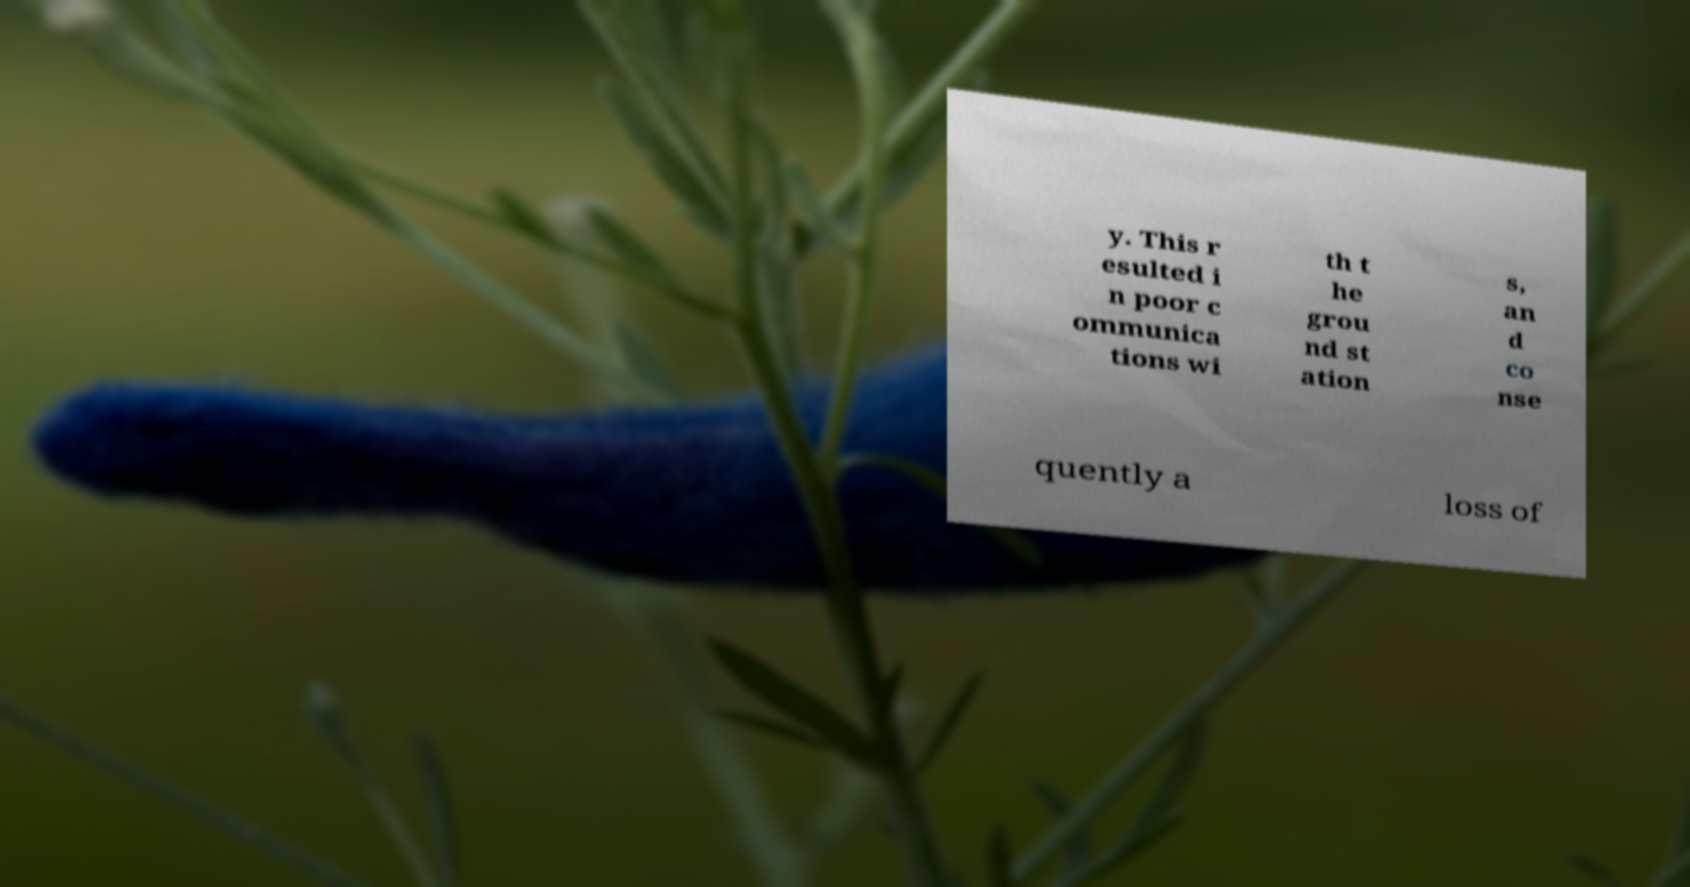Can you read and provide the text displayed in the image?This photo seems to have some interesting text. Can you extract and type it out for me? y. This r esulted i n poor c ommunica tions wi th t he grou nd st ation s, an d co nse quently a loss of 